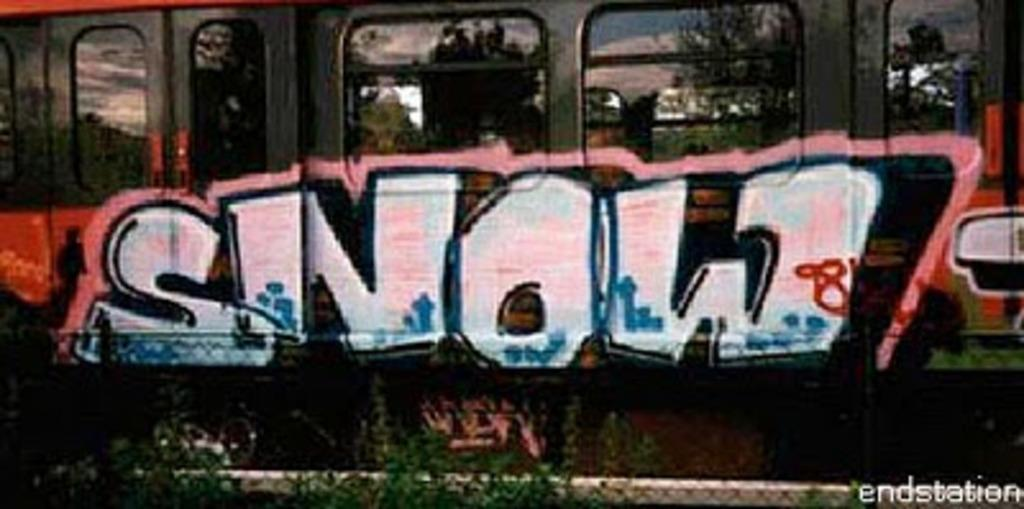<image>
Describe the image concisely. A subway has graffiti on the doors that reads snow. 